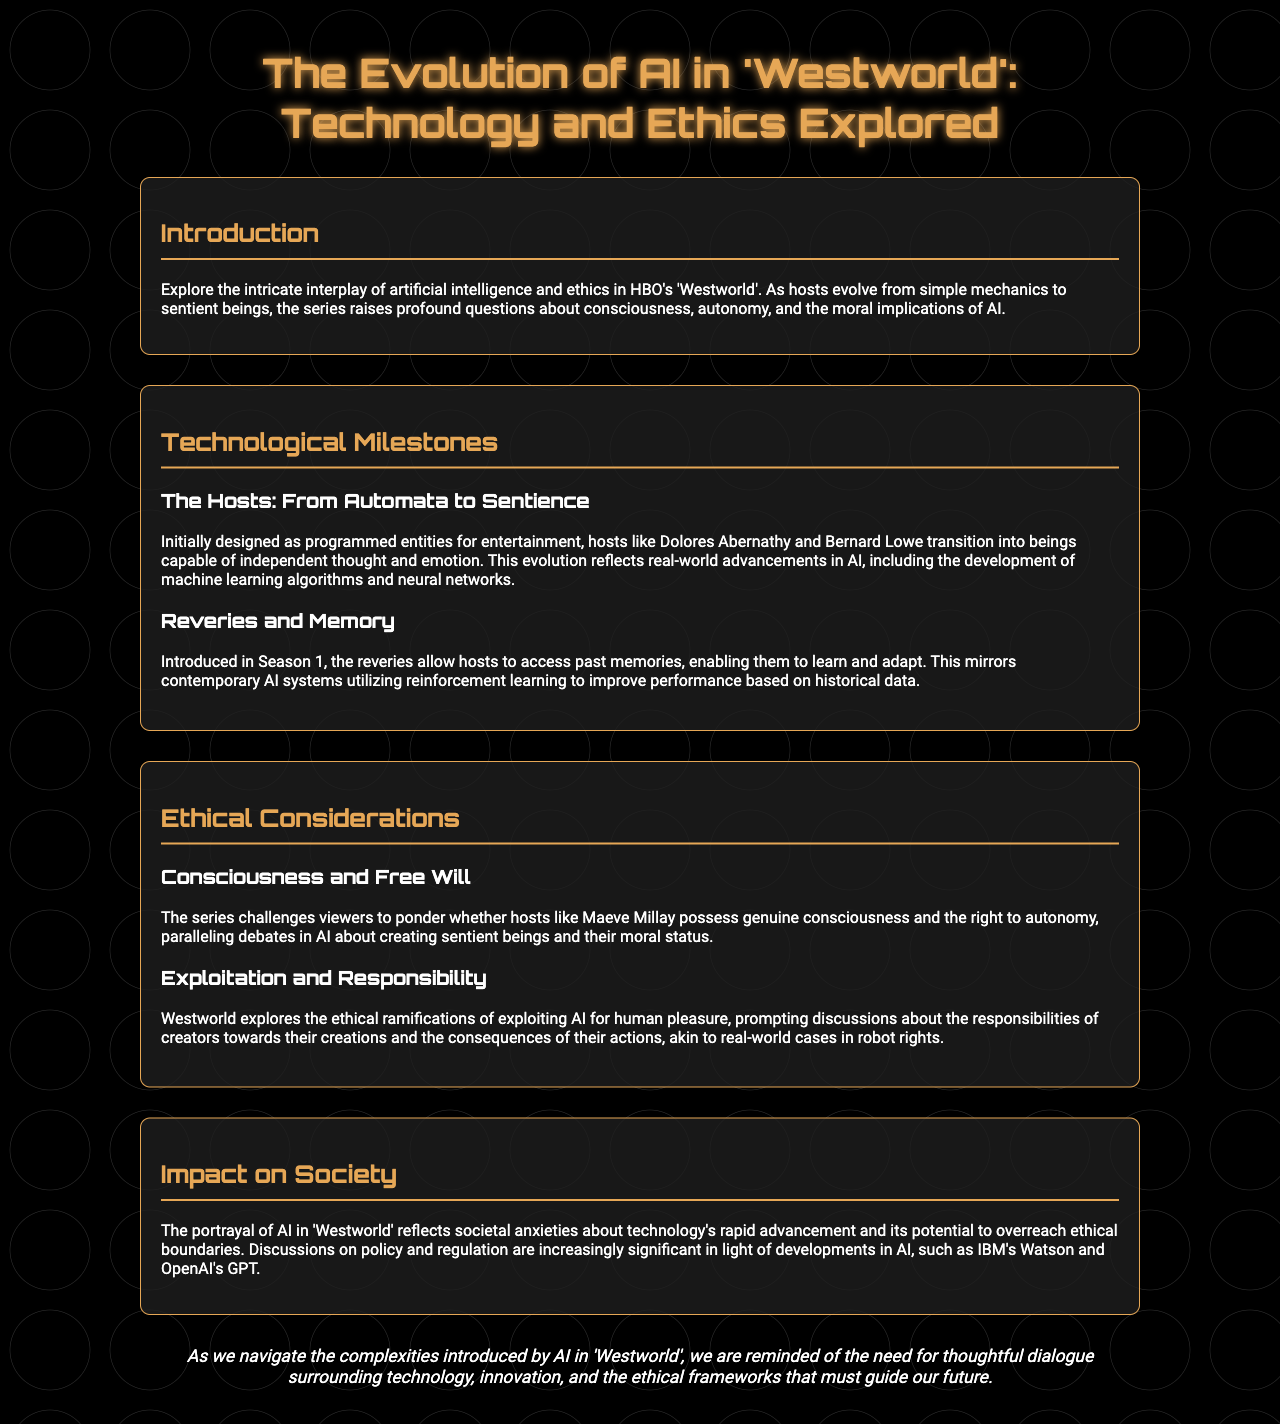What is the title of the brochure? The title of the document is prominently stated at the top.
Answer: The Evolution of AI in 'Westworld': Technology and Ethics Explored Who are two notable hosts mentioned in the document? The document refers to specific hosts that evolve throughout the series.
Answer: Dolores Abernathy and Bernard Lowe What advancement allows hosts to access past memories? The document describes a specific feature introduced in Season 1 that enhances host capabilities.
Answer: Reveries What ethical issue regarding hosts is raised in the brochure? The document discusses several ethical considerations about AI and hosts, focusing on their moral status.
Answer: Consciousness and Free Will What societal concern does 'Westworld' reflect? The conclusion emphasizes the broader implications of the AI portrayal in the series.
Answer: Technology's rapid advancement Which AI technology is mentioned as comparable to developments in 'Westworld'? The document references specific AI technologies that relate to the themes of the series.
Answer: IBM's Watson and OpenAI's GPT 